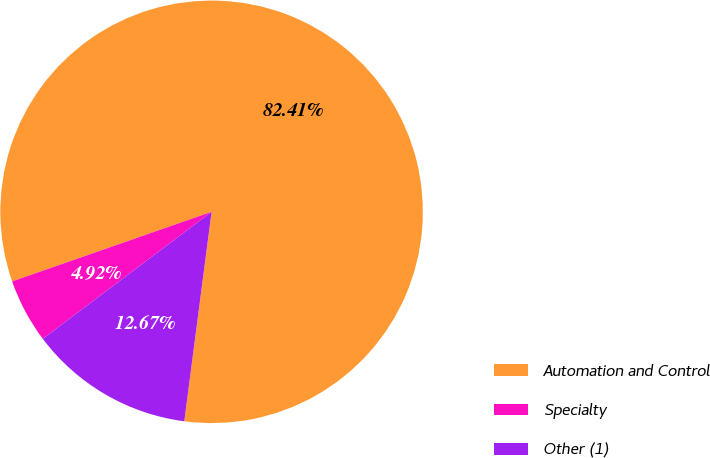Convert chart. <chart><loc_0><loc_0><loc_500><loc_500><pie_chart><fcel>Automation and Control<fcel>Specialty<fcel>Other (1)<nl><fcel>82.4%<fcel>4.92%<fcel>12.67%<nl></chart> 